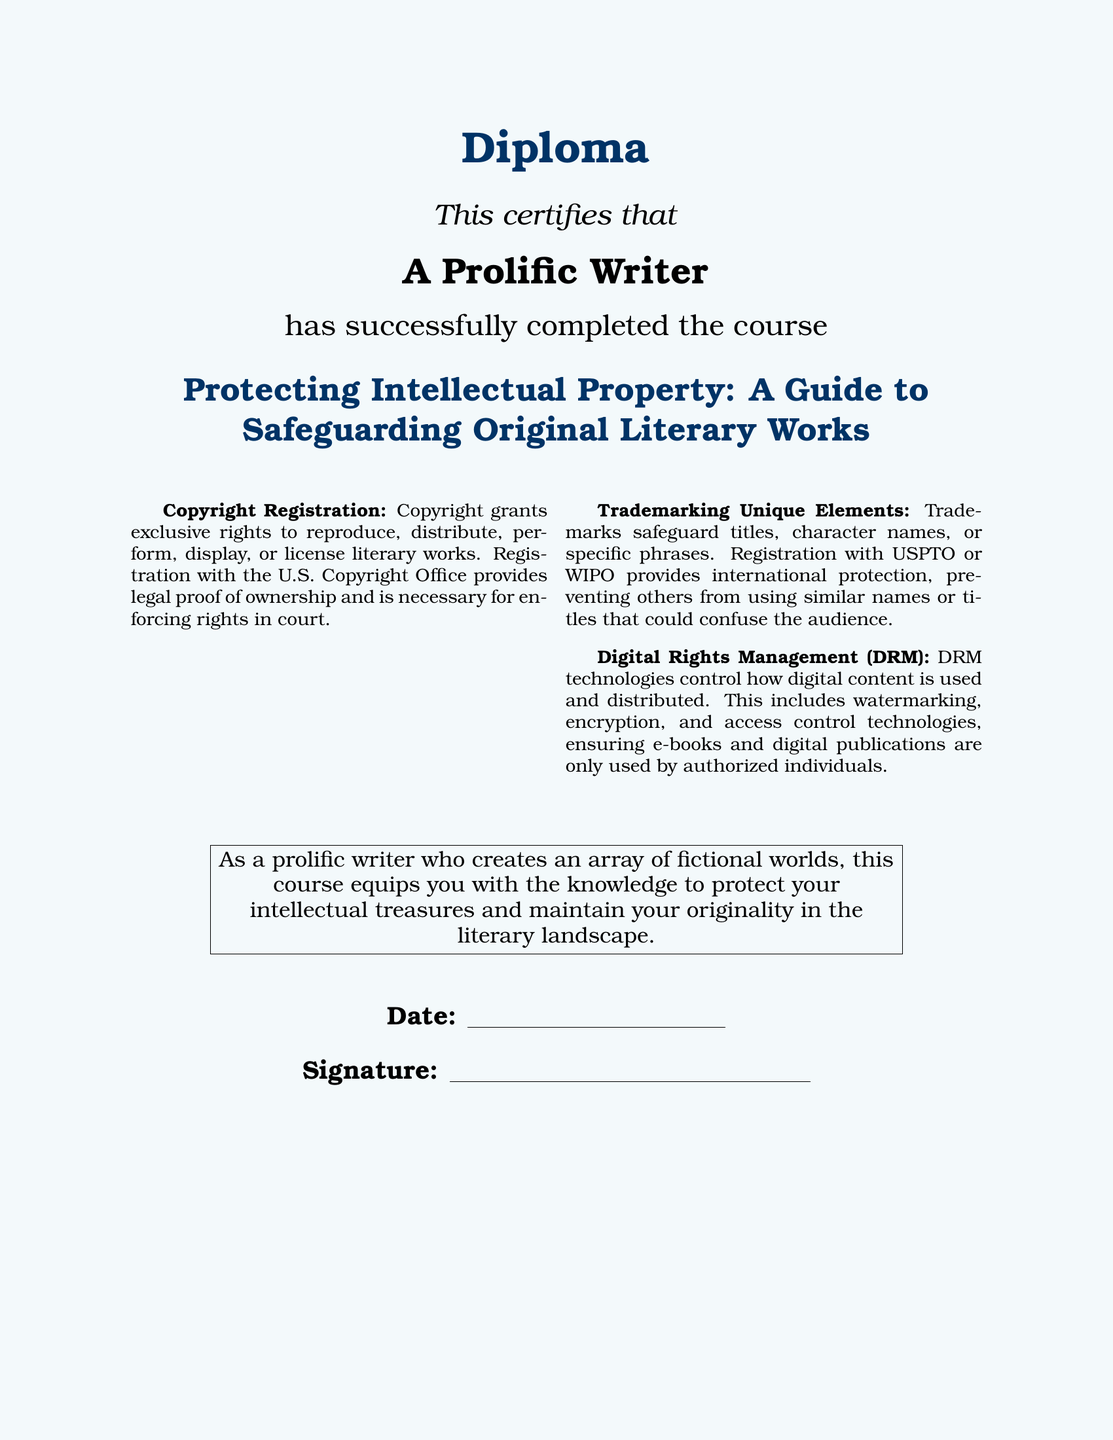What is the title of the course? The title is explicitly stated in the document as the course provided to the individual.
Answer: Protecting Intellectual Property: A Guide to Safeguarding Original Literary Works Who is this diploma awarded to? The diploma explicitly certifies a specific individual is the recipient of the accomplishment mentioned.
Answer: A Prolific Writer What does copyright registration provide? The document outlines a key benefit of copyright registration for literary works, detailing ownership rights.
Answer: Legal proof of ownership What is the abbreviation for the U.S. Copyright Office? The document mentions the government agency involved in copyright registration by its common name.
Answer: U.S. Copyright Office What does DRM stand for? The acronym is defined in the context of controlling digital content use in the document.
Answer: Digital Rights Management What is one purpose of trademarking in literature? The document provides a brief explanation of what trademarks safeguard specifically within literary works.
Answer: Safeguard titles, character names, or specific phrases What color is used for the diploma title? The document specifies the color used for the prominent text on the diploma, enhancing visual appeal.
Answer: Deep blue When was this diploma issued? The document includes a section where the date of issuance should be filled in, indicating when the diploma is valid.
Answer: \underline{\hspace{5cm}} 